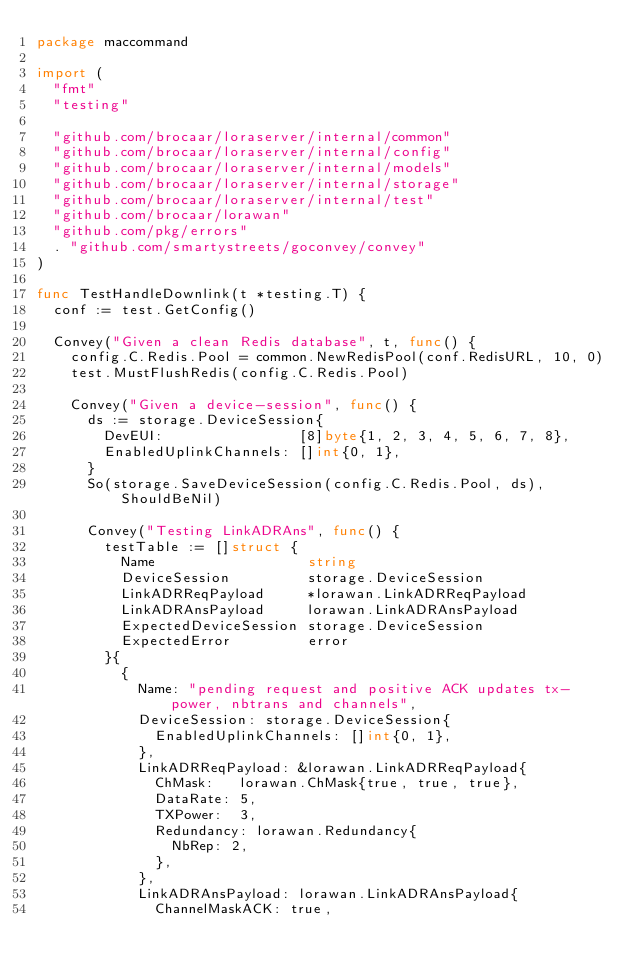Convert code to text. <code><loc_0><loc_0><loc_500><loc_500><_Go_>package maccommand

import (
	"fmt"
	"testing"

	"github.com/brocaar/loraserver/internal/common"
	"github.com/brocaar/loraserver/internal/config"
	"github.com/brocaar/loraserver/internal/models"
	"github.com/brocaar/loraserver/internal/storage"
	"github.com/brocaar/loraserver/internal/test"
	"github.com/brocaar/lorawan"
	"github.com/pkg/errors"
	. "github.com/smartystreets/goconvey/convey"
)

func TestHandleDownlink(t *testing.T) {
	conf := test.GetConfig()

	Convey("Given a clean Redis database", t, func() {
		config.C.Redis.Pool = common.NewRedisPool(conf.RedisURL, 10, 0)
		test.MustFlushRedis(config.C.Redis.Pool)

		Convey("Given a device-session", func() {
			ds := storage.DeviceSession{
				DevEUI:                [8]byte{1, 2, 3, 4, 5, 6, 7, 8},
				EnabledUplinkChannels: []int{0, 1},
			}
			So(storage.SaveDeviceSession(config.C.Redis.Pool, ds), ShouldBeNil)

			Convey("Testing LinkADRAns", func() {
				testTable := []struct {
					Name                  string
					DeviceSession         storage.DeviceSession
					LinkADRReqPayload     *lorawan.LinkADRReqPayload
					LinkADRAnsPayload     lorawan.LinkADRAnsPayload
					ExpectedDeviceSession storage.DeviceSession
					ExpectedError         error
				}{
					{
						Name: "pending request and positive ACK updates tx-power, nbtrans and channels",
						DeviceSession: storage.DeviceSession{
							EnabledUplinkChannels: []int{0, 1},
						},
						LinkADRReqPayload: &lorawan.LinkADRReqPayload{
							ChMask:   lorawan.ChMask{true, true, true},
							DataRate: 5,
							TXPower:  3,
							Redundancy: lorawan.Redundancy{
								NbRep: 2,
							},
						},
						LinkADRAnsPayload: lorawan.LinkADRAnsPayload{
							ChannelMaskACK: true,</code> 